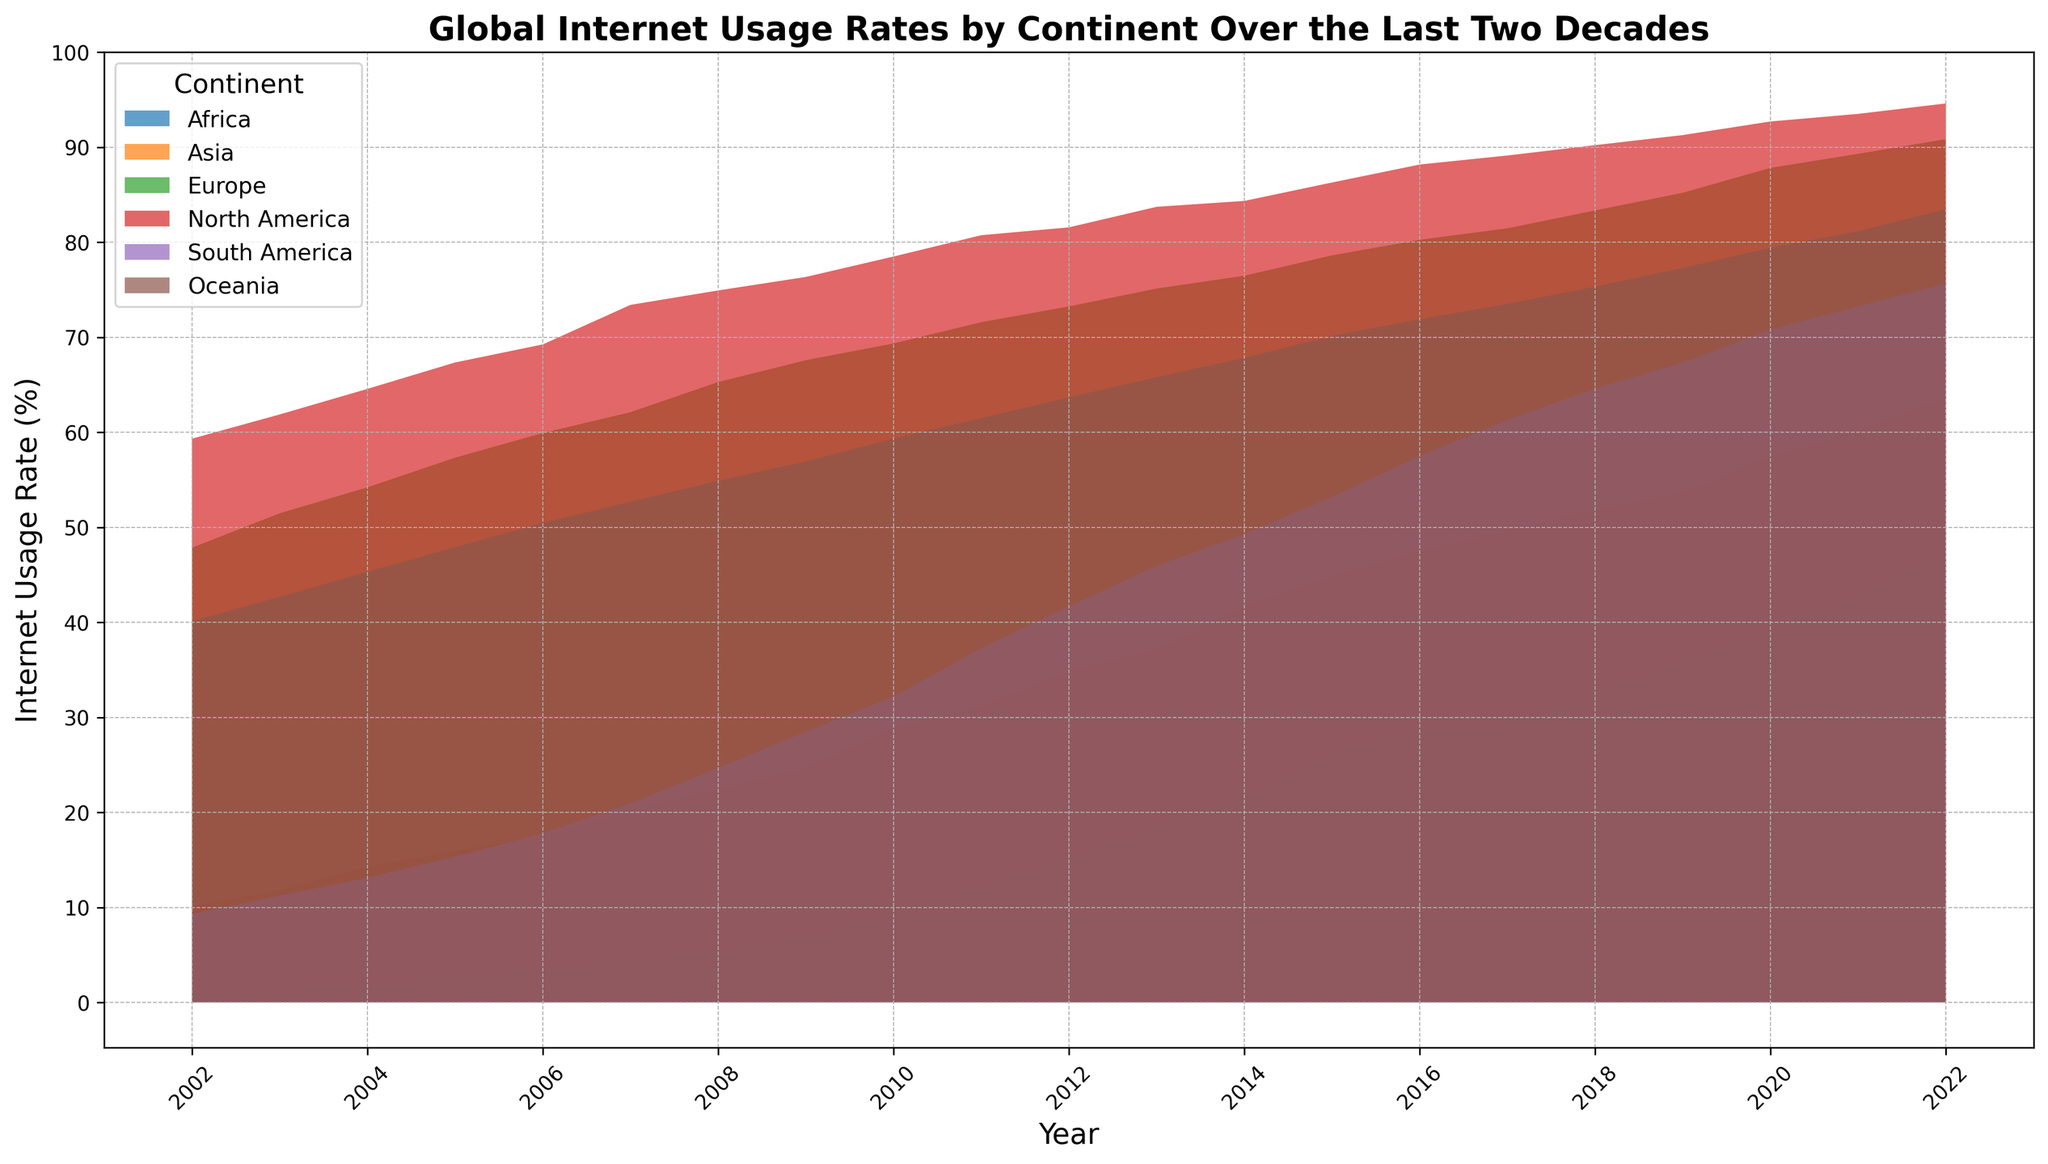Which continent had the highest internet usage rate in 2002? Look at the 2002 data points and see which continent's area reaches the highest position on the y-axis. For 2002, Europe has the highest rate according to the figure.
Answer: Europe Which continent showed the most significant increase in internet usage rate from 2010 to 2022? Compare the heights for each continent between 2010 and 2022, and observe the increase in area height. Africa's area shows the most significant upward trend.
Answer: Africa How does the internet usage rate in Asia in 2012 compare to that in Europe? Find the 2012 data points for both Asia and Europe and compare their heights on the y-axis. Europe's rate is much higher than Asia's.
Answer: Europe is higher Which year did North America reach an internet usage rate of approximately 80%? Scan the North America data trend and find when the area reaches around 80% on the y-axis. This occurs around 2011.
Answer: 2011 In 2022, which continents had an internet usage rate exceeding 75%? Look at the 2022 data points and determine which continents have areas reaching above 75% on the y-axis. Europe, North America, and Oceania all exceed 75%.
Answer: Europe, North America, Oceania What is the rough average internet usage rate for South America in the first five years (2002-2006)? Sum the values for South America from 2002 to 2006 and divide by 5. The values are 9.31, 11.24, 13.12, 15.34, and 17.79, summing to 66.8. The average is 66.8/5 = 13.36
Answer: 13.36 How did the internet usage rate for Oceania change from 2018 to 2022? Compare the 2018 and 2022 data points for Oceania by noting the heights on the y-axis. The rate increased from 75.32% to 83.47%.
Answer: Increased Between 2007 and 2009, which continent saw an increase of over 5% in internet usage rate? Check the changes for all continents between 2007 and 2009. South America increased from 20.94% to 28.49%, which is an increase of 7.55%.
Answer: South America In which decade did Africa experience the most growth in internet usage rates? Compare the area changes for Africa over each decade. The most significant growth occurred between 2010 and 2020.
Answer: 2010-2020 By 2020, how many continents had reached over 50% internet usage rate? Look at the 2020 data points and count the continents with areas extending above 50% on the y-axis. Asia, Europe, North America, South America, and Oceania all exceed 50%.
Answer: 5 